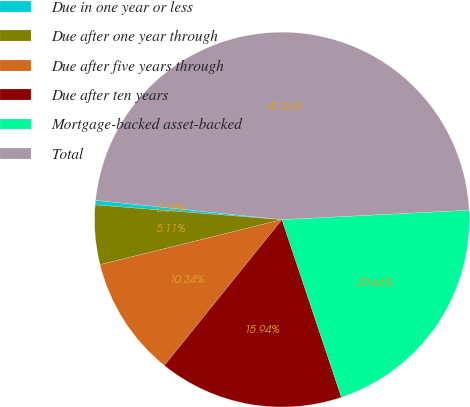<chart> <loc_0><loc_0><loc_500><loc_500><pie_chart><fcel>Due in one year or less<fcel>Due after one year through<fcel>Due after five years through<fcel>Due after ten years<fcel>Mortgage-backed asset-backed<fcel>Total<nl><fcel>0.39%<fcel>5.11%<fcel>10.34%<fcel>15.94%<fcel>20.66%<fcel>47.56%<nl></chart> 